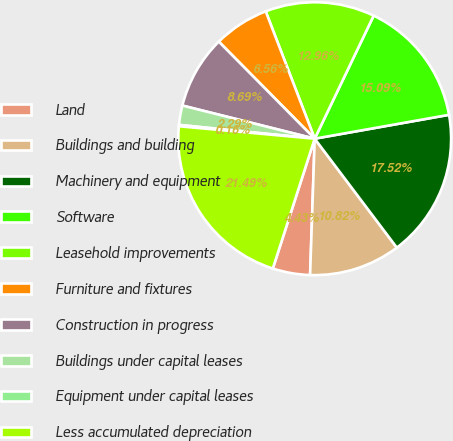Convert chart. <chart><loc_0><loc_0><loc_500><loc_500><pie_chart><fcel>Land<fcel>Buildings and building<fcel>Machinery and equipment<fcel>Software<fcel>Leasehold improvements<fcel>Furniture and fixtures<fcel>Construction in progress<fcel>Buildings under capital leases<fcel>Equipment under capital leases<fcel>Less accumulated depreciation<nl><fcel>4.43%<fcel>10.82%<fcel>17.52%<fcel>15.09%<fcel>12.96%<fcel>6.56%<fcel>8.69%<fcel>2.29%<fcel>0.16%<fcel>21.49%<nl></chart> 